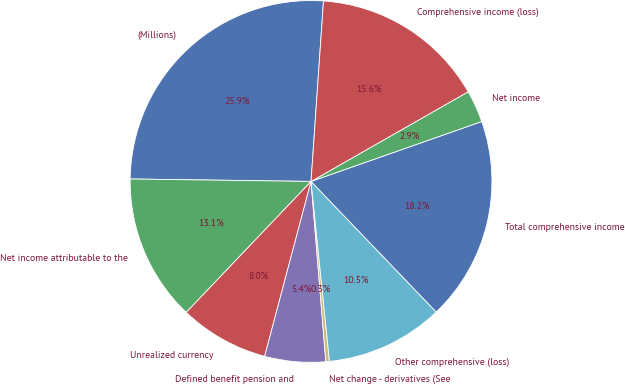Convert chart. <chart><loc_0><loc_0><loc_500><loc_500><pie_chart><fcel>(Millions)<fcel>Net income attributable to the<fcel>Unrealized currency<fcel>Defined benefit pension and<fcel>Net change - derivatives (See<fcel>Other comprehensive (loss)<fcel>Total comprehensive income<fcel>Net income<fcel>Comprehensive income (loss)<nl><fcel>25.88%<fcel>13.1%<fcel>7.99%<fcel>5.43%<fcel>0.32%<fcel>10.54%<fcel>18.21%<fcel>2.88%<fcel>15.65%<nl></chart> 